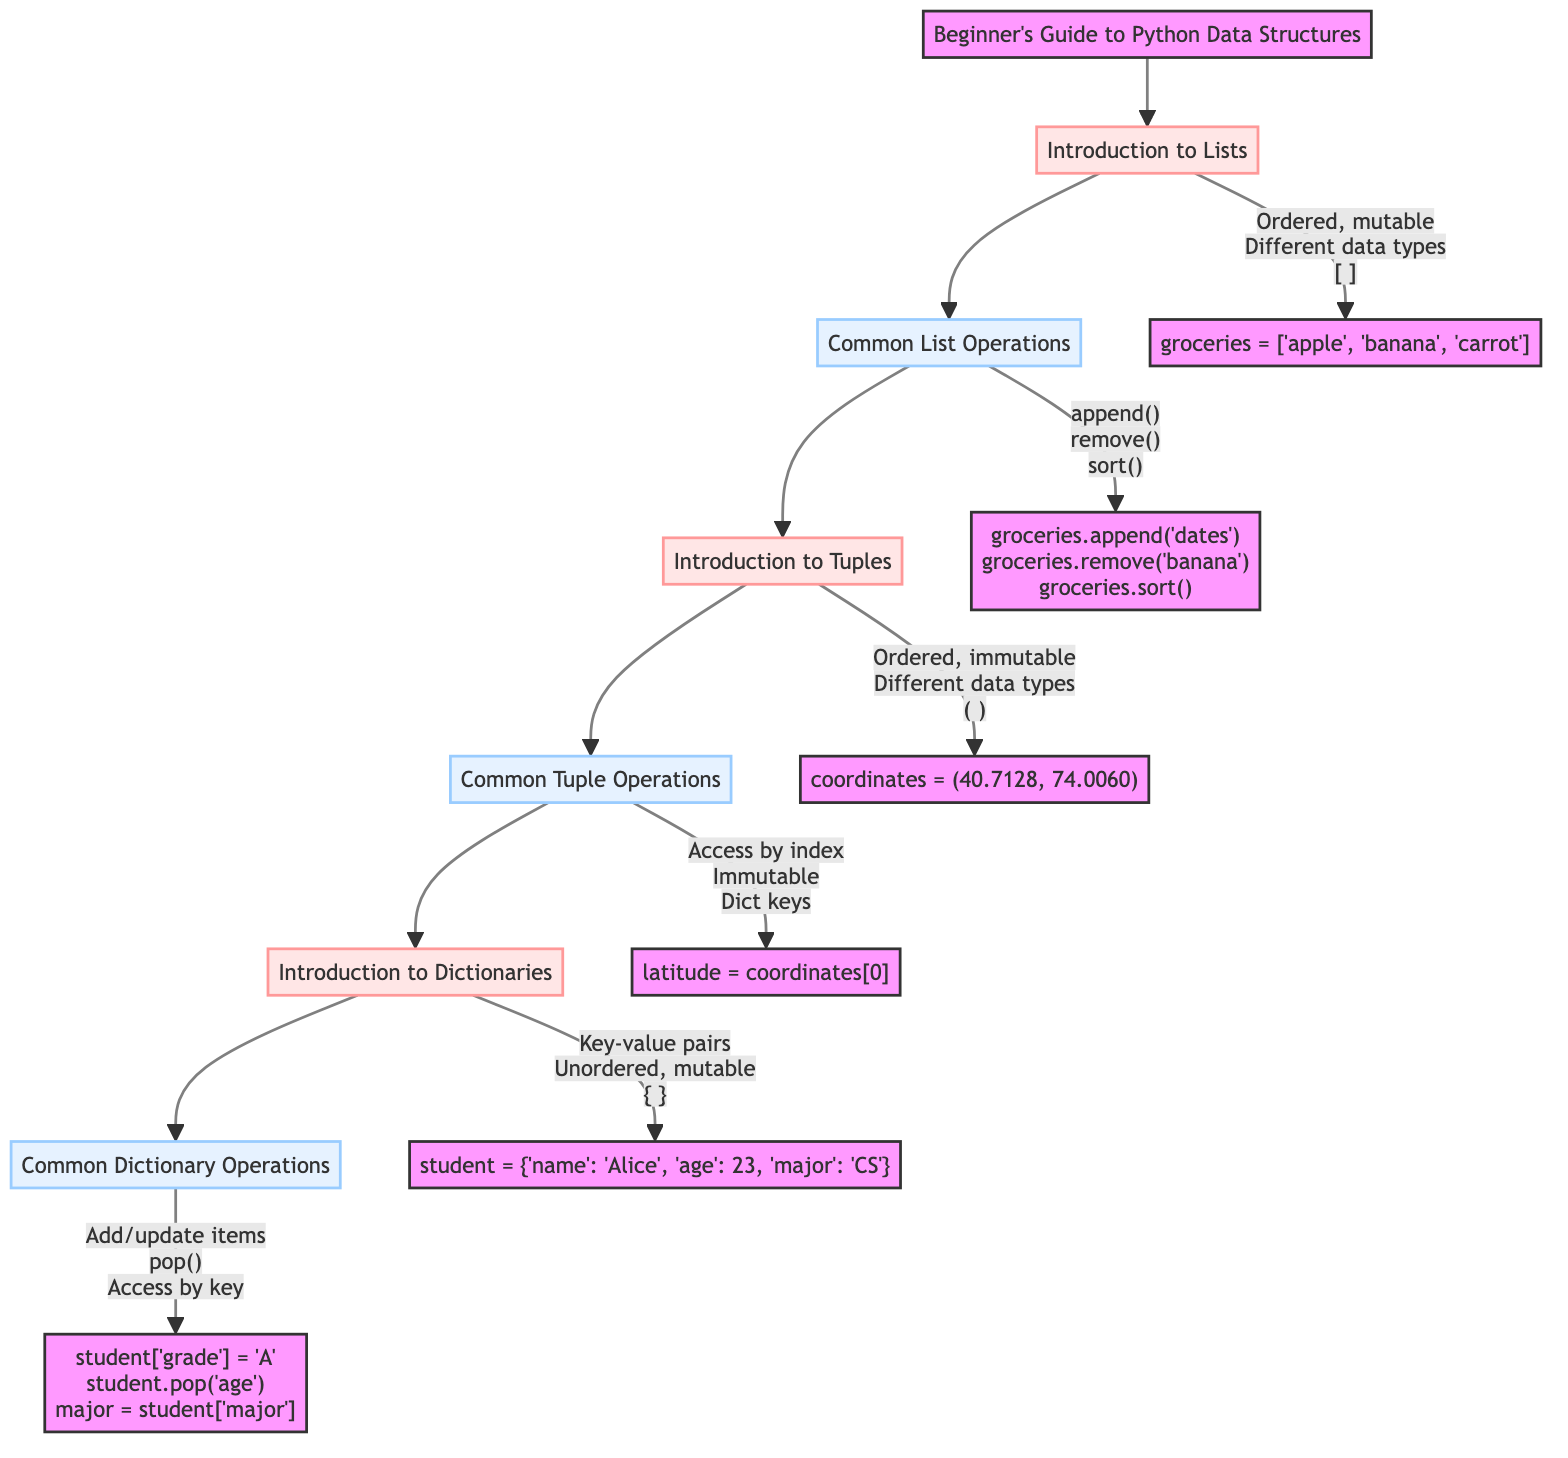What is the first step in the pathway? The first step mentioned in the diagram is "Introduction to Lists," which is also the entry point into the clinical pathway.
Answer: Introduction to Lists How many main data structures are introduced in the pathway? The diagram presents three main data structures: Lists, Tuples, and Dictionaries, as outlined in the flow from one step to the next.
Answer: Three Which operation is associated with the "Common Dictionary Operations" step? The operations listed for this step are adding, updating items, removing items, and accessing items by key, specifically highlighted in the flow.
Answer: Add/update items What is the key characteristic of Tuples highlighted in the pathway? The pathway specifies that Tuples are immutable, meaning once created, their contents cannot change, as indicated under the Introduction to Tuples.
Answer: Immutable What follows after "Common List Operations"? The diagram clearly shows a flow from "Common List Operations" to "Introduction to Tuples," indicating the next topic in the pathway.
Answer: Introduction to Tuples Which data structure is defined using curly braces? According to the "Introduction to Dictionaries" step, Dictionaries are defined using curly braces, highlighting their syntax.
Answer: Curly braces What method is indicated for removing an item from a list? The diagram notes that the remove() method is used for removing items from a list, which is a fundamental operation shown in the "Common List Operations" section.
Answer: remove() How are items accessed in a Tuple? The pathway explains that items in a Tuple can be accessed by their index, which is a common operation highlighted in the "Common Tuple Operations."
Answer: By index What example is provided for a Dictionary? The "Introduction to Dictionaries" section gives the example: student = {'name': 'Alice', 'age': 23, 'major': 'Computer Science'}, which illustrates its structure.
Answer: student = {'name': 'Alice', 'age': 23, 'major': 'Computer Science'} 